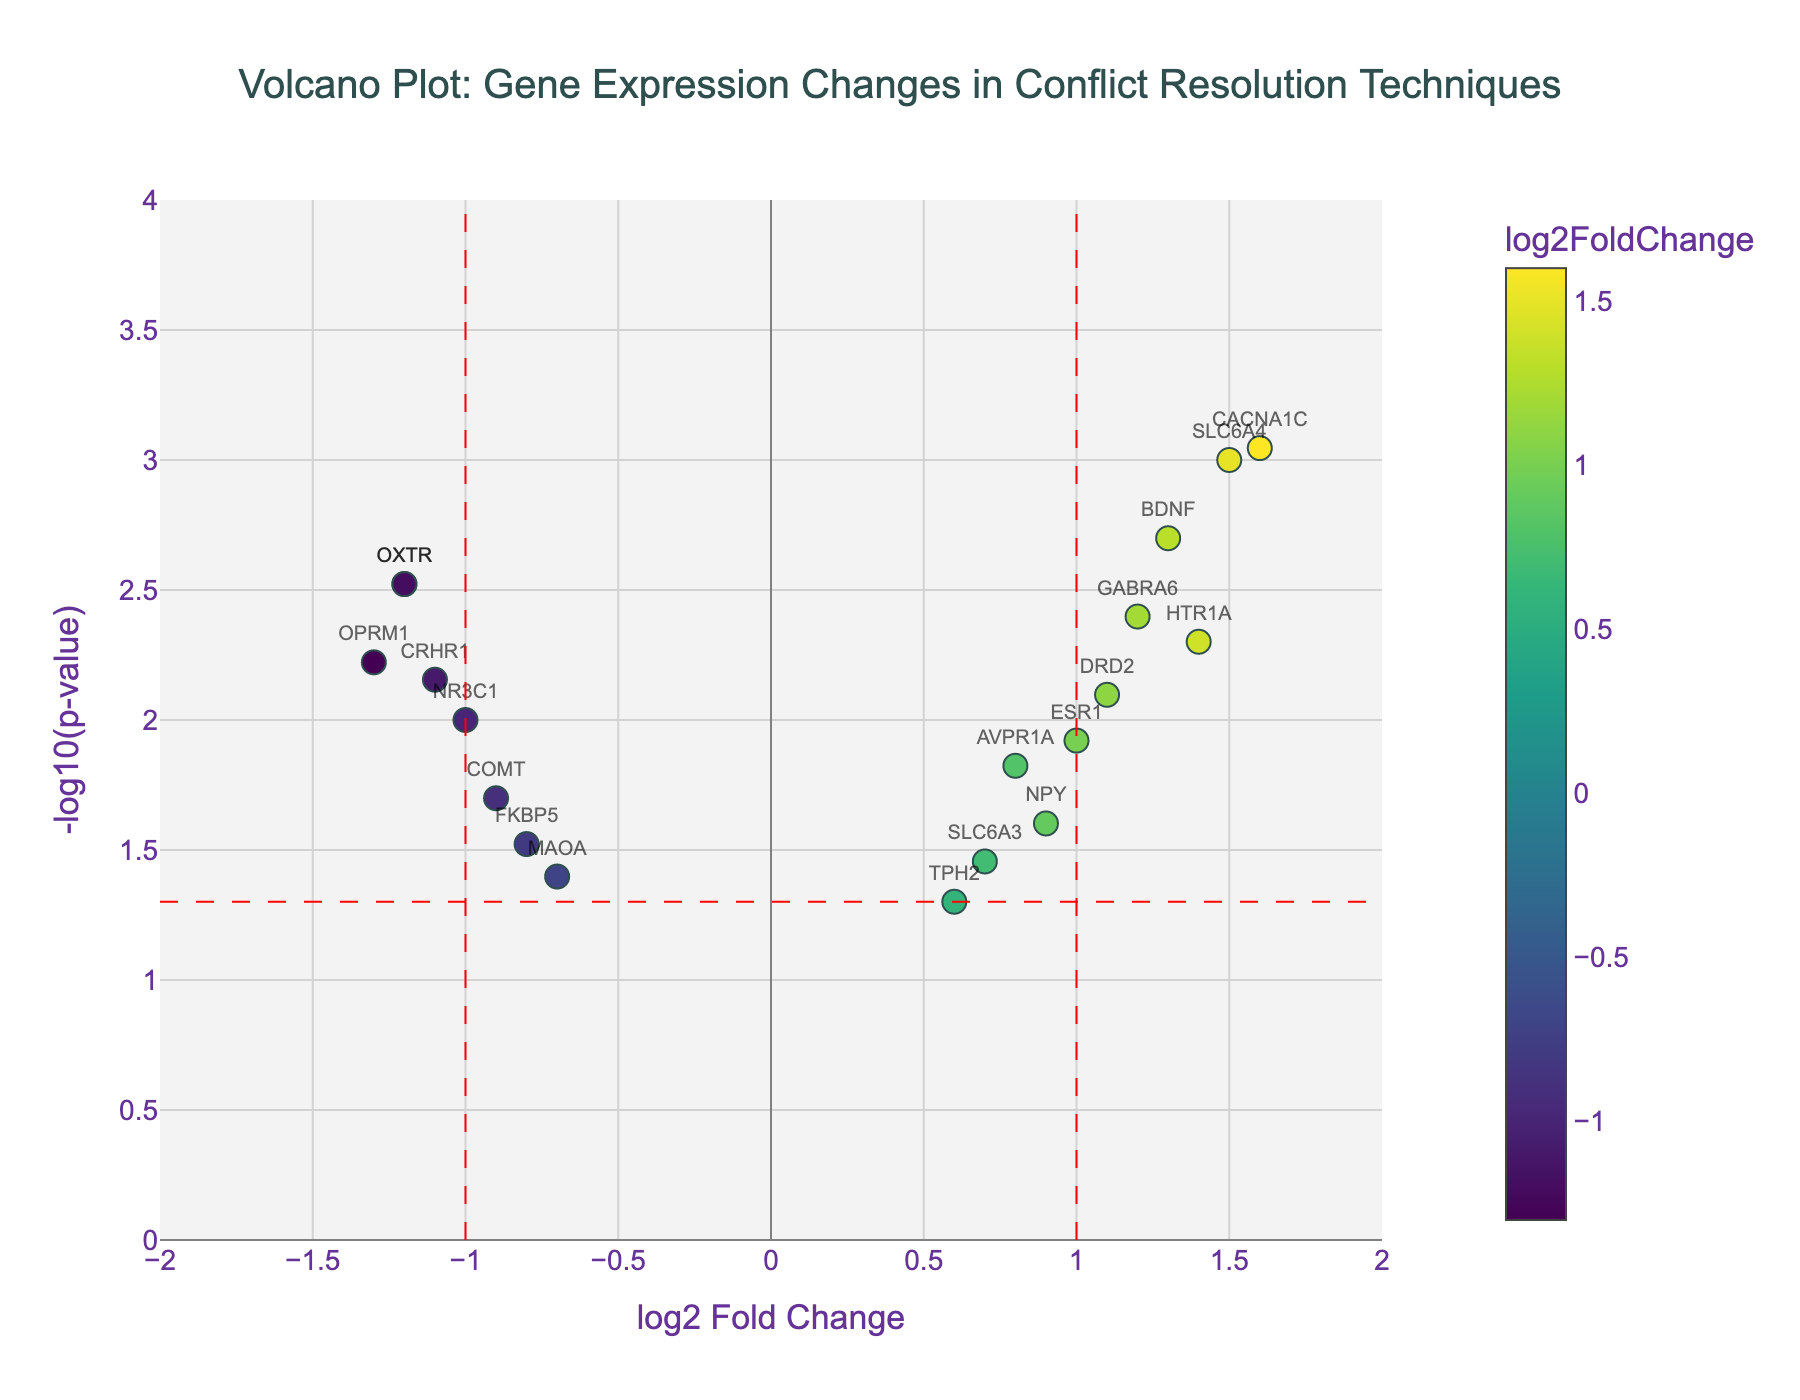What is the title of the Volcano Plot? The title of the plot is typically found at the top of the figure. In this case, it directly states what the plot represents in the context of gene expression changes related to conflict resolution techniques.
Answer: "Volcano Plot: Gene Expression Changes in Conflict Resolution Techniques" How many genes have a log2FoldChange greater than 1? To answer this, look at the x-axis for points right of the vertical line at log2FoldChange = 1. Count the number of points in this region.
Answer: 6 genes Which gene has the highest -log10(p-value)? Identify the point with the highest y-coordinate on the plot, and read the gene label associated with that point. The highest point indicates the smallest p-value.
Answer: CACNA1C What does the red vertical line at log2FoldChange = 1 indicate? The red vertical lines are commonly used to indicate a threshold. In this context, points to the right of the red line at log2FoldChange = 1 indicate genes with significantly increased expression levels.
Answer: Threshold for significant up-regulation Which genes have significant down-regulation? Look for genes positioned to the left of the vertical red line at log2FoldChange = -1 and above the horizontal red line indicating p-value significance. The genes OXTR, CRHR1, NR3C1, and OPRM1 fall in this region.
Answer: OXTR, CRHR1, NR3C1, OPRM1 What does the color of the points represent in the plot? Examine the colorbar shown on the right of the plot. The color intensity corresponds to the log2FoldChange values, ranging from more negative (blue-yellow) to more positive (green).
Answer: log2FoldChange values Which gene has the lowest log2FoldChange? Check the x-axis for the point with the most negative log2FoldChange value. In the figure, that value is around -1.3.
Answer: OPRM1 What is the threshold for statistical significance in the p-value? The horizontal red line marks this threshold, which represents a -log10(p-value) corresponding to a p-value of 0.05. The calculation is -log10(0.05).
Answer: 1.301 Are there more up-regulated or down-regulated genes? Count the number of points to the right of the vertical red line at log2FoldChange = 1 (up-regulated) and to the left of the vertical red line at log2FoldChange = -1 (down-regulated).
Answer: More up-regulated genes Which gene has a log2FoldChange closest to zero but is still statistically significant? Look for the point closest to the line x=0, above the horizontal line marking p-value significance. Examine the hovertext for precise values.
Answer: AVPR1A 